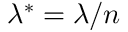<formula> <loc_0><loc_0><loc_500><loc_500>\lambda ^ { * } = \lambda / n</formula> 